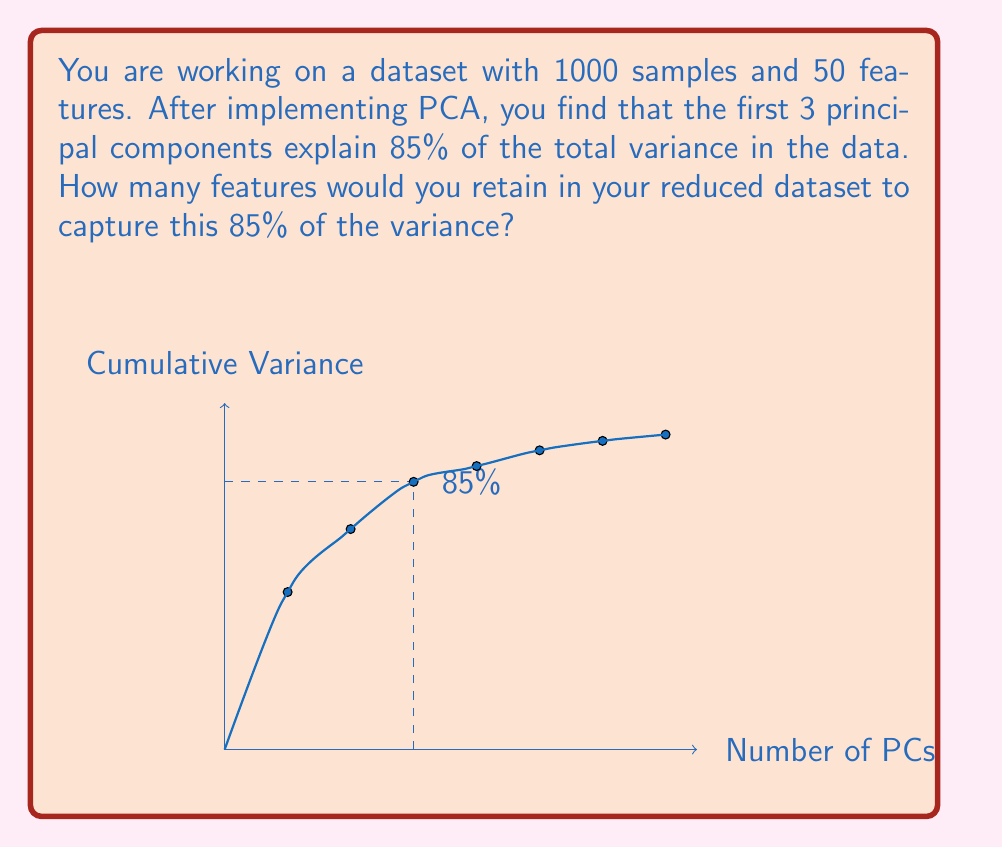Help me with this question. To solve this problem, we need to understand the concept of Principal Component Analysis (PCA) and how it relates to variance explained. Here's a step-by-step explanation:

1. PCA is a dimensionality reduction technique that transforms the original features into a new set of uncorrelated variables called principal components (PCs).

2. These PCs are ordered by the amount of variance they explain in the data, with the first PC explaining the most variance, the second PC explaining the second most, and so on.

3. The cumulative variance explained is the sum of the variance explained by each PC up to that point.

4. In this case, we're told that the first 3 PCs explain 85% of the total variance.

5. The question asks how many features we would retain to capture this 85% of the variance.

6. Since PCA creates new features (the PCs) that are linear combinations of the original features, each PC can be considered a new feature.

7. Therefore, to retain 85% of the variance, we need to keep the number of PCs that explain that much variance.

8. We're given that the first 3 PCs explain 85% of the variance.

Thus, we would retain 3 features (the first 3 PCs) in our reduced dataset to capture 85% of the variance.

This approach significantly reduces the dimensionality of the dataset from 50 original features to just 3 PCs, while still retaining most of the important information in the data.
Answer: 3 